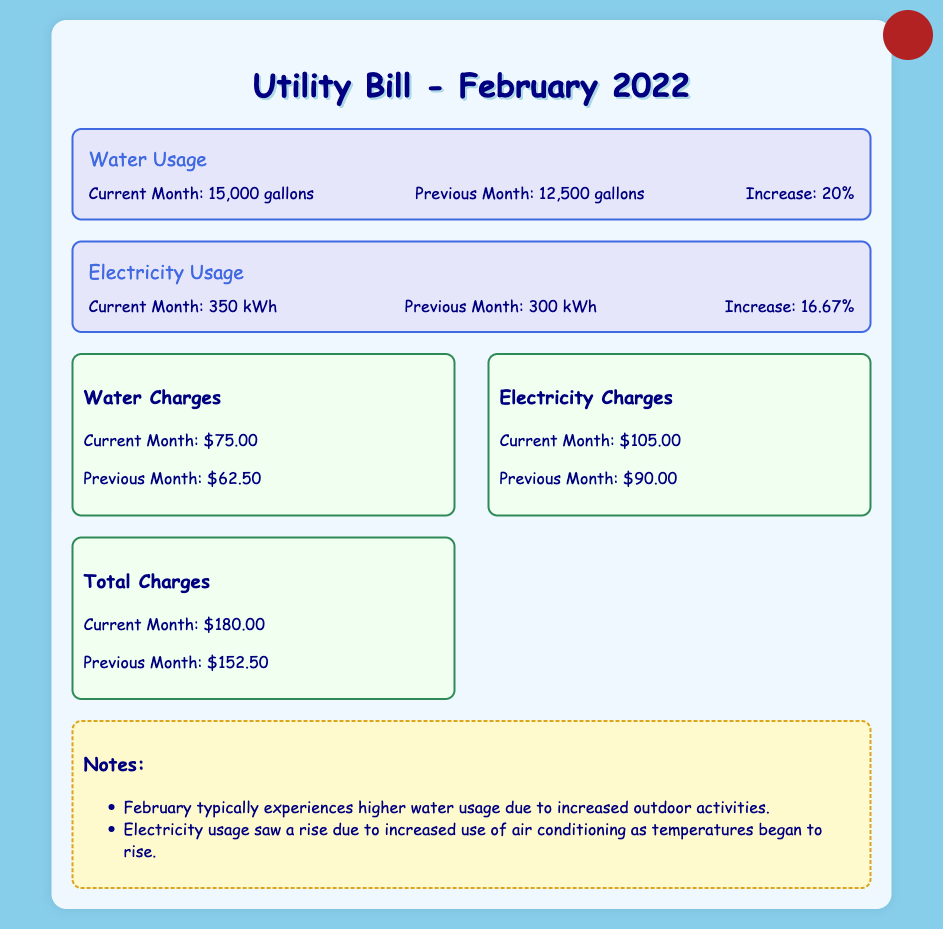What was the water usage in February 2022? The document states that water usage was 15,000 gallons in February 2022.
Answer: 15,000 gallons What was the previous month's electricity usage? The document indicates that the previous month's electricity usage was 300 kWh.
Answer: 300 kWh How much did the water charges increase from the previous month? The water charges increased from $62.50 in the previous month to $75.00 in February 2022, which is a change of $12.50.
Answer: $12.50 What percentage increase did water usage experience in February 2022? The document shows that water usage increased by 20% from the previous month to February 2022.
Answer: 20% What were the total charges for February 2022? The total charges for February 2022 were $180.00 according to the document.
Answer: $180.00 What note explains the increase in electricity usage? The document notes that electricity usage saw a rise due to increased use of air conditioning as temperatures began to rise.
Answer: Increased use of air conditioning How much did electricity charges increase from the previous month? The increase in electricity charges is $15.00, from $90.00 to $105.00 in February 2022.
Answer: $15.00 What are the water charges for the previous month? The document states that the water charges for the previous month were $62.50.
Answer: $62.50 How much electricity was used in kWh for February 2022? February 2022 saw electricity usage of 350 kWh according to the document.
Answer: 350 kWh 